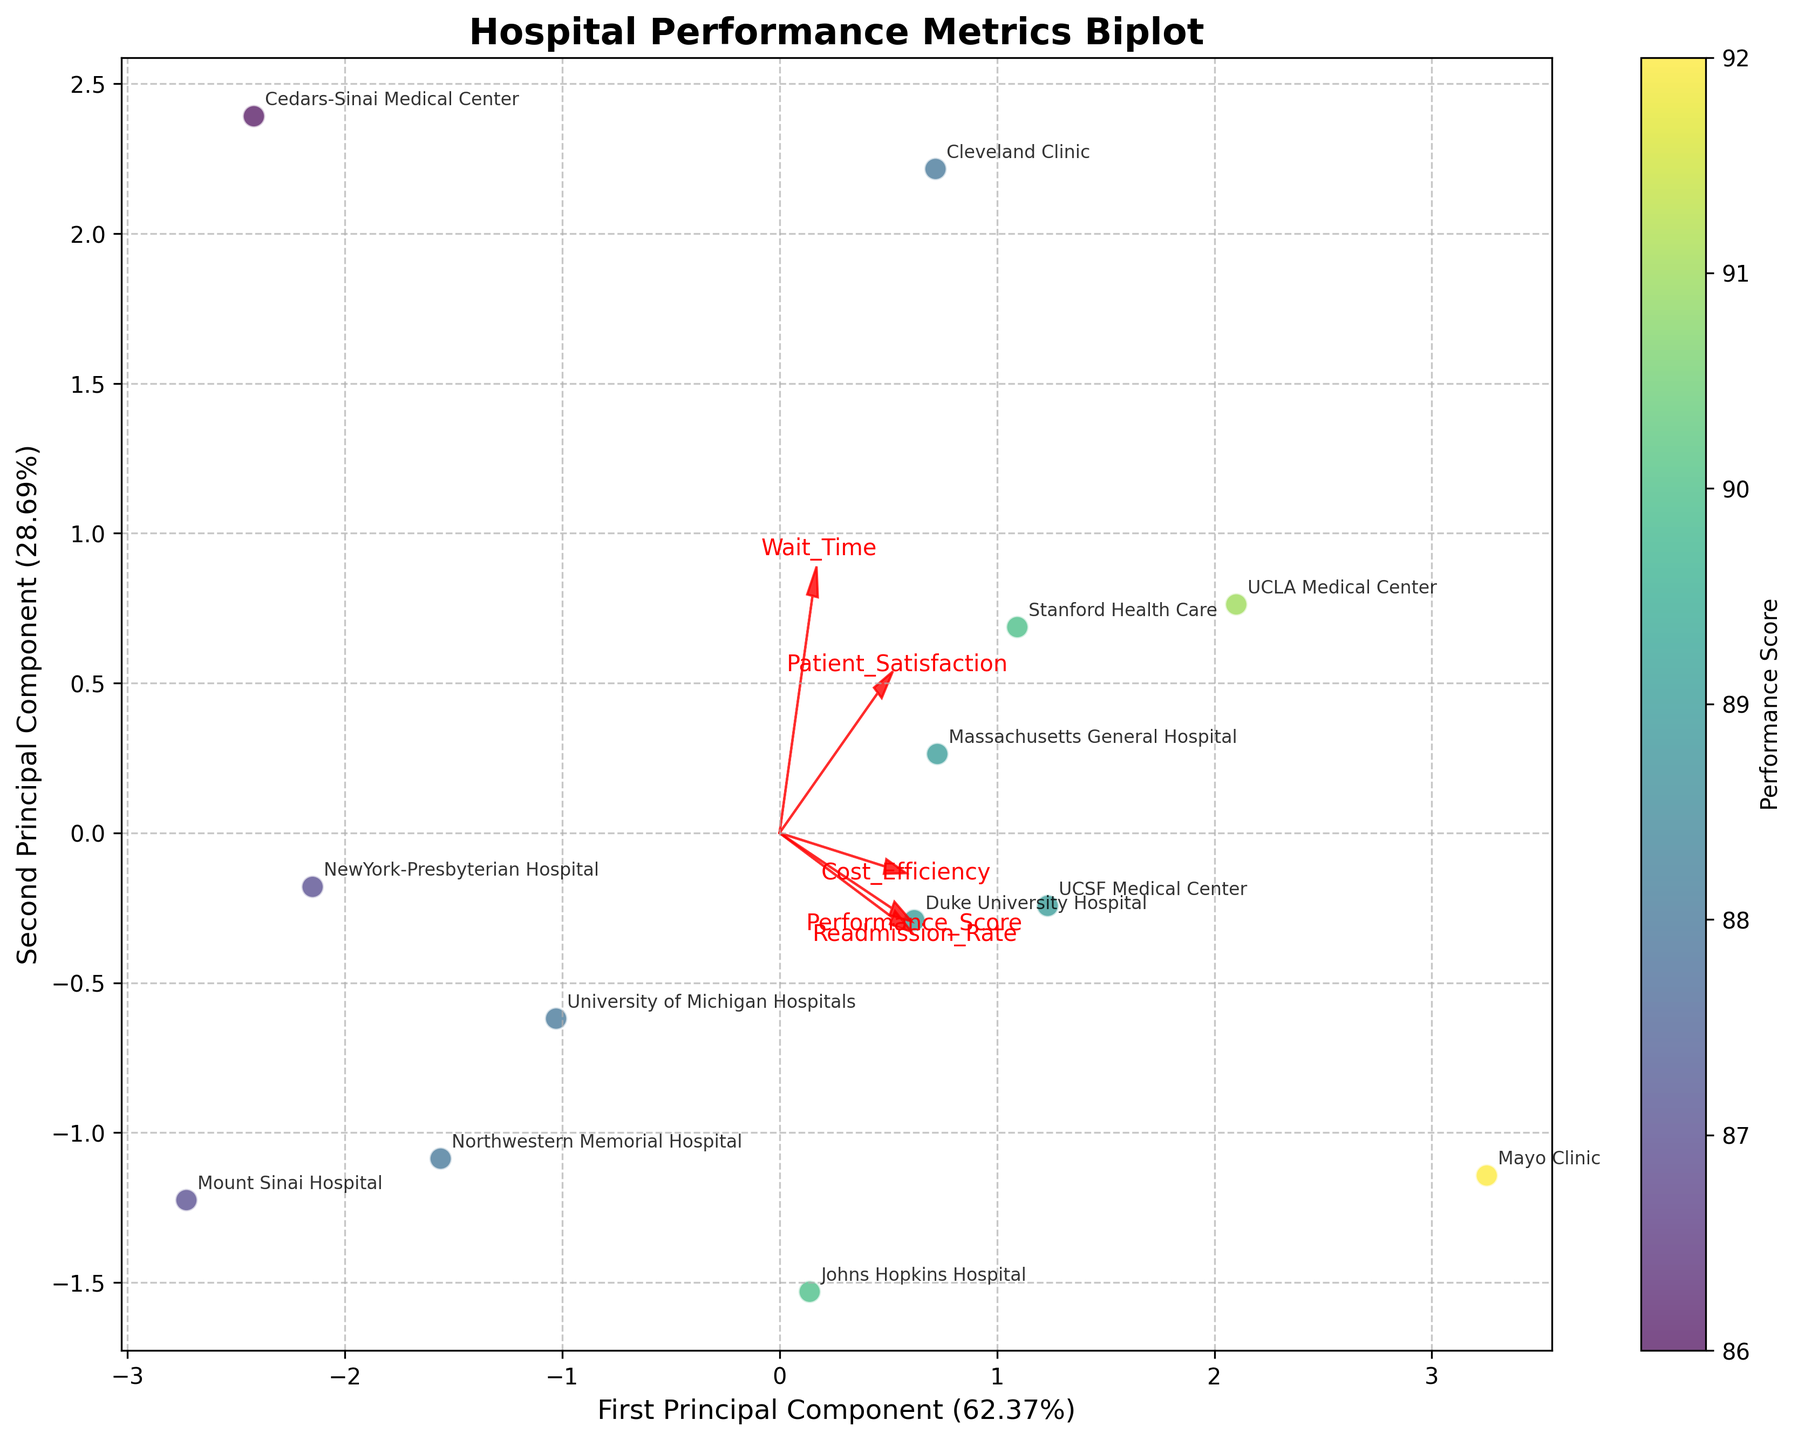What's the title of the plot? The title of the plot is located at the top center of the figure. By reading it, you can determine the main subject of the visualization.
Answer: Hospital Performance Metrics Biplot What do the arrows in the plot represent? The arrows represent feature vectors of the data; each arrow points in the direction of a particular feature (e.g., Performance Score, Patient Satisfaction) and indicates how strongly that feature influences the principal components.
Answer: Feature vectors Which hospital has the highest Performance Score based on the color intensity in the plot? The color intensity on the scatter plot is based on the Performance Score. By examining which point has the highest intensity (corresponding to deepest color), you can identify the hospital with the highest score.
Answer: Mayo Clinic How many principal components are represented on the axes of the biplot? The labels of the axes indicate the number of principal components represented. Both x and y axes will have Principal Component labels.
Answer: 2 Which hospital group has similar levels of Performance Score and Patient Satisfaction? By examining groups of data points that are closely clustered together, you can infer that the hospitals in these clusters have similar scores. For example, identify which group of data points clustered closely within the plot and label them.
Answer: Massachusetts General Hospital, UCSF Medical Center, Duke University Hospital, Stanford Health Care How much variance is explained by the first principal component and the second principal component? The percentage variance explained by each principal component is noted next to the axis labels. Sum these percentages to get the explained variance for each principal component.
Answer: First: Approximately 37.10%; Second: Approximately 26.03% What feature has the strongest influence on the second principal component? By looking at which arrow aligns most closely with the direction of the axis labeled "Second Principal Component," you can determine which feature has the strongest influence.
Answer: Patient Satisfaction Which hospital is most closely associated with high Readmission Rate based on the arrows? By analyzing the data point that falls in the same direction as the arrow labeled "Readmission Rate," you can identify the associated hospital.
Answer: Mayo Clinic Which hospitals are located in the lower-left quadrant of the biplot and what does this imply about their performance metrics? Observe the labels and coordinates of the data points in the lower-left quadrant. These hospitals might have lower values in the principal components, reflecting certain performance metrics.
Answer: Johns Hopkins Hospital, Mount Sinai Hospital, NewYork-Presbyterian Hospital What can you infer about the clustering pattern in the plot regarding hospitals' Performance Score and Patient Satisfaction? Analyze how the data points are clustered and their corresponding labels. This can reveal if there is a relationship or correlation between the Performance Score and Patient Satisfaction. For example, hospitals grouped closely might have similar scores.
Answer: Similar clusters for Performance Score and Patient Satisfaction 